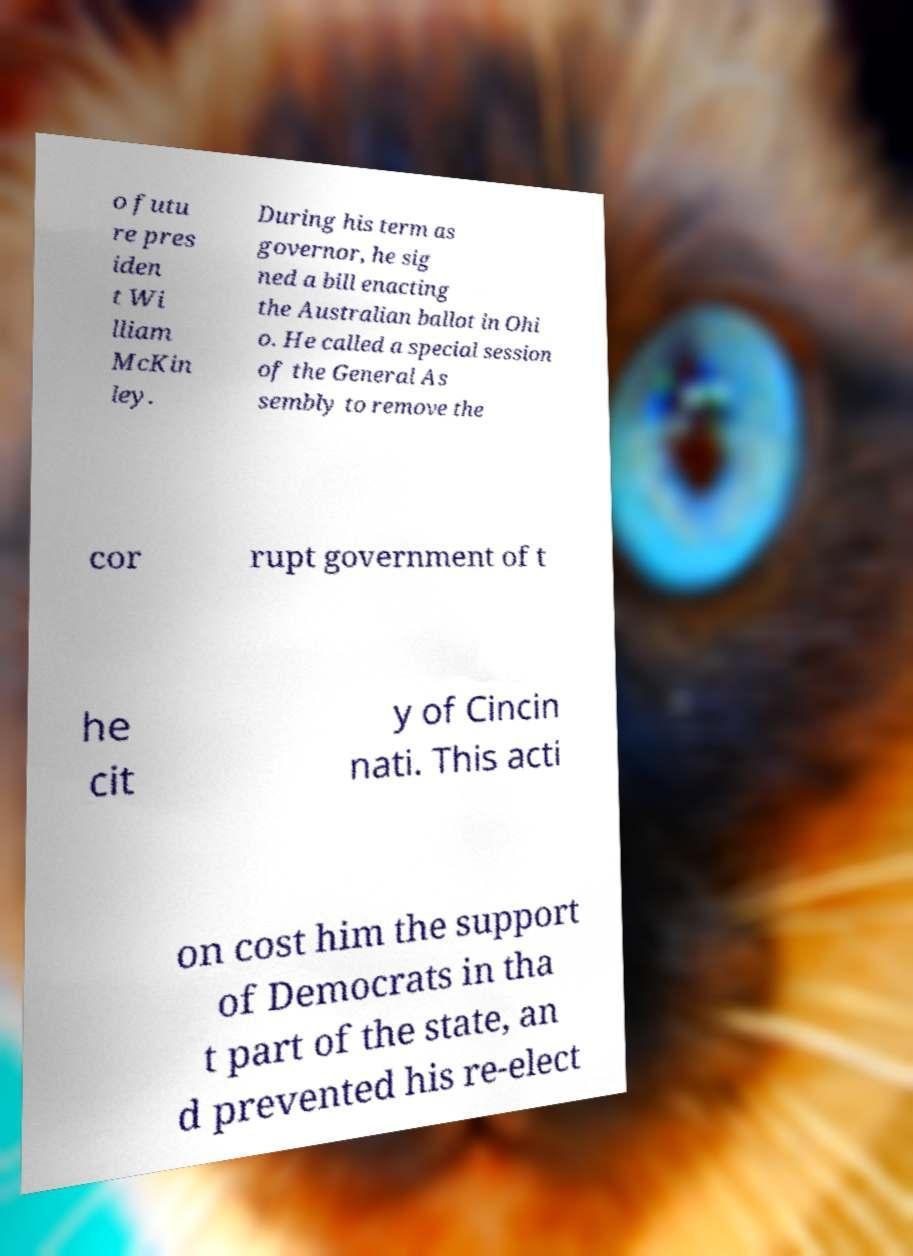For documentation purposes, I need the text within this image transcribed. Could you provide that? o futu re pres iden t Wi lliam McKin ley. During his term as governor, he sig ned a bill enacting the Australian ballot in Ohi o. He called a special session of the General As sembly to remove the cor rupt government of t he cit y of Cincin nati. This acti on cost him the support of Democrats in tha t part of the state, an d prevented his re-elect 